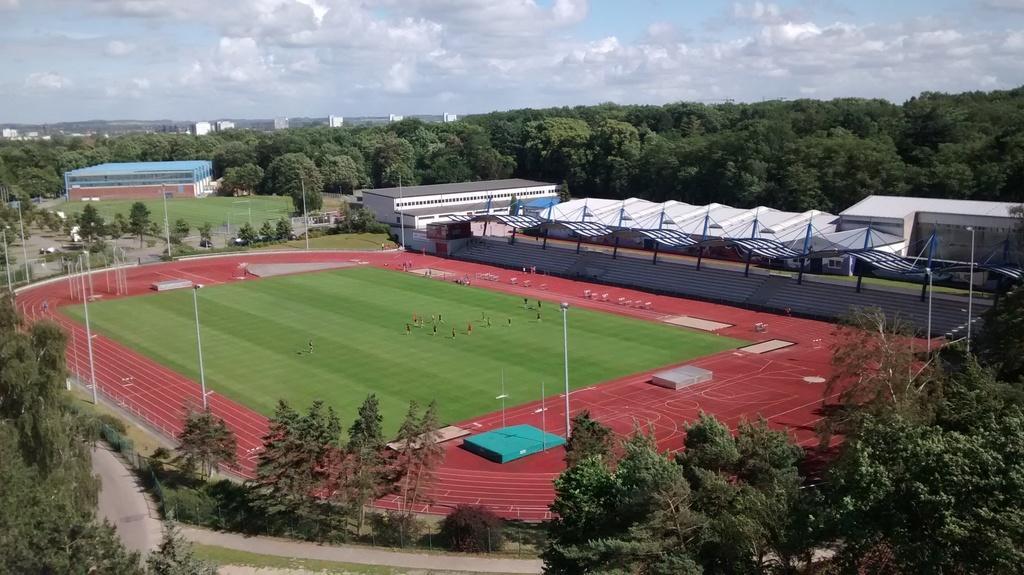Please provide a concise description of this image. In this image we can see a stadium with some players. We can also see stairs, roof, trees, road, poles, lights and grass. On the backside we can see a group of trees, buildings and the sky which looks cloudy. 